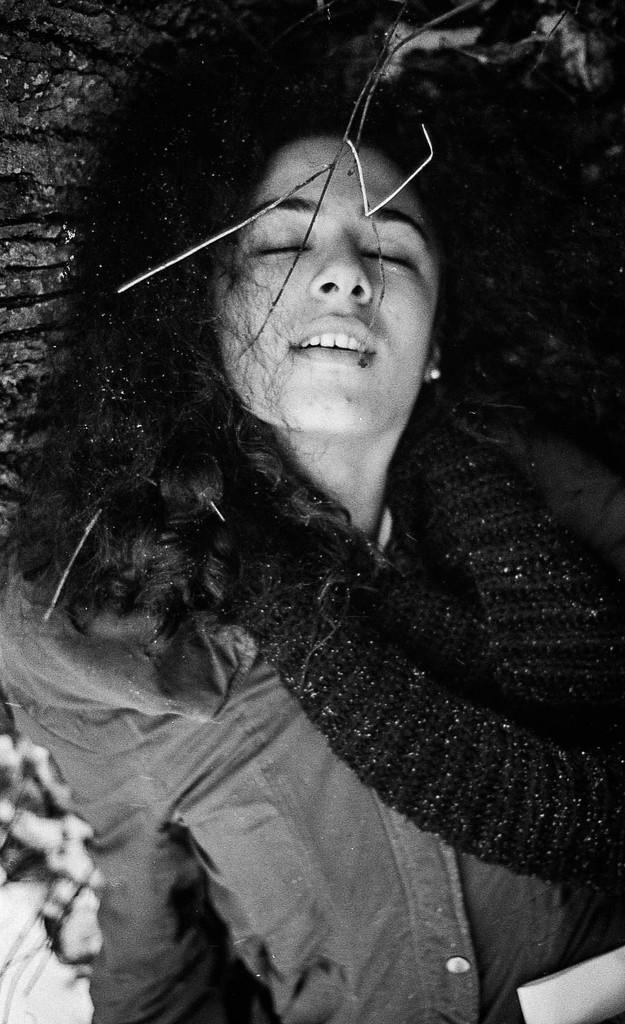What is the color scheme of the image? The image is black and white. Who is the main subject in the image? There is a girl in the image. What type of clothing is the girl wearing? The girl is wearing a jacket and a woolen scarf. How many stamps are visible on the girl's jacket in the image? There are no stamps visible on the girl's jacket in the image. What time is displayed on the clocks in the image? There are no clocks present in the image. 